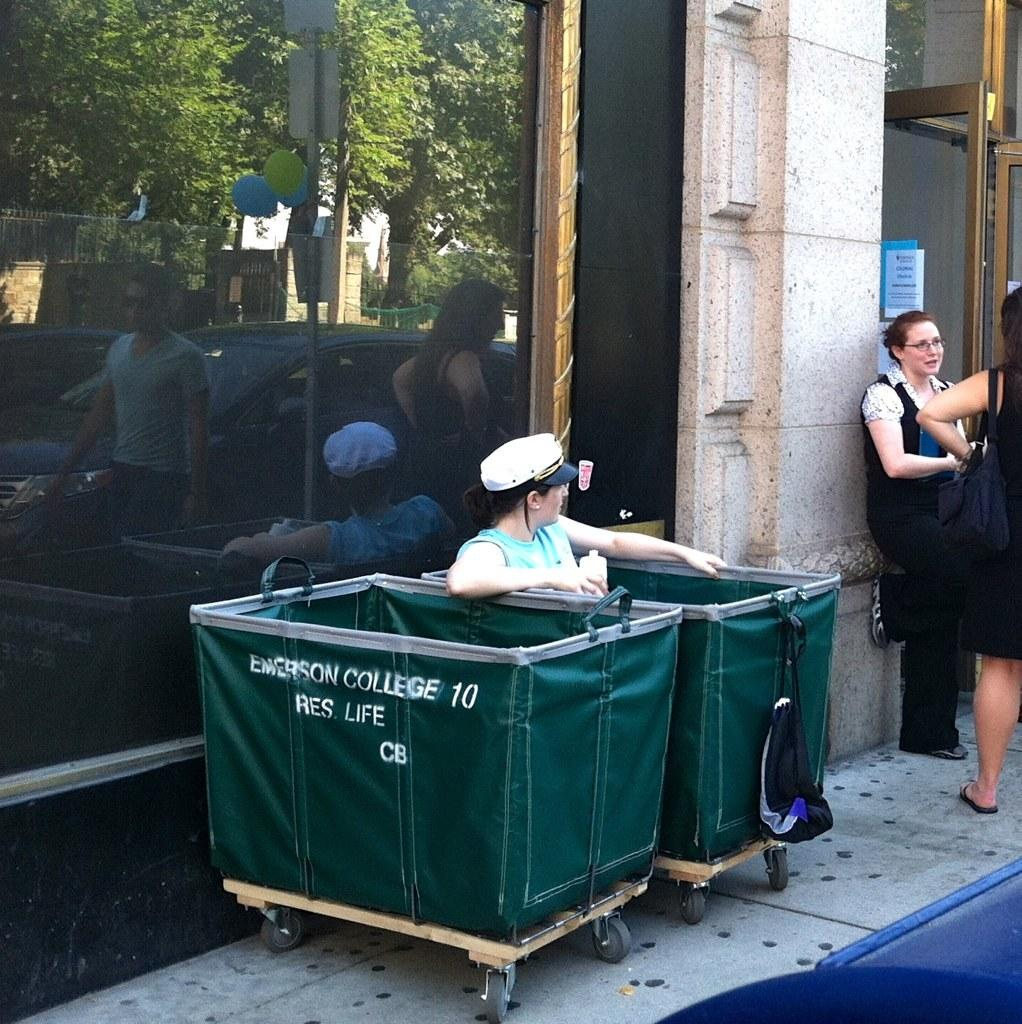<image>
Create a compact narrative representing the image presented. Two green colored trash bin from emerson college 10 